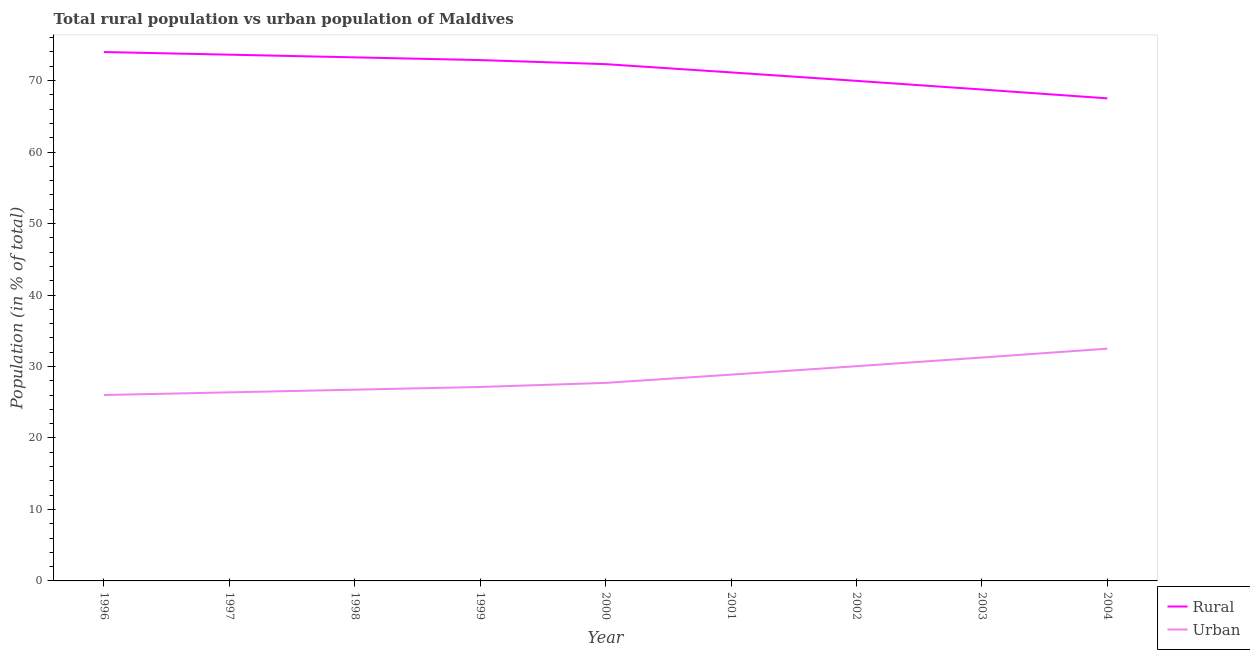Is the number of lines equal to the number of legend labels?
Offer a terse response. Yes. What is the rural population in 1999?
Ensure brevity in your answer.  72.87. Across all years, what is the maximum rural population?
Your answer should be compact. 73.99. Across all years, what is the minimum rural population?
Your answer should be compact. 67.51. What is the total urban population in the graph?
Give a very brief answer. 256.62. What is the difference between the rural population in 2002 and that in 2003?
Keep it short and to the point. 1.21. What is the difference between the rural population in 2004 and the urban population in 1997?
Your response must be concise. 41.13. What is the average urban population per year?
Make the answer very short. 28.51. In the year 1997, what is the difference between the urban population and rural population?
Keep it short and to the point. -47.24. In how many years, is the urban population greater than 34 %?
Give a very brief answer. 0. What is the ratio of the urban population in 1999 to that in 2002?
Your response must be concise. 0.9. Is the difference between the rural population in 1997 and 2004 greater than the difference between the urban population in 1997 and 2004?
Your response must be concise. Yes. What is the difference between the highest and the second highest rural population?
Your answer should be very brief. 0.37. What is the difference between the highest and the lowest rural population?
Offer a terse response. 6.48. In how many years, is the rural population greater than the average rural population taken over all years?
Your answer should be compact. 5. Is the rural population strictly greater than the urban population over the years?
Keep it short and to the point. Yes. Is the urban population strictly less than the rural population over the years?
Offer a terse response. Yes. Are the values on the major ticks of Y-axis written in scientific E-notation?
Keep it short and to the point. No. Does the graph contain any zero values?
Give a very brief answer. No. Does the graph contain grids?
Keep it short and to the point. No. Where does the legend appear in the graph?
Ensure brevity in your answer.  Bottom right. How many legend labels are there?
Your response must be concise. 2. What is the title of the graph?
Your answer should be compact. Total rural population vs urban population of Maldives. Does "Investment in Transport" appear as one of the legend labels in the graph?
Make the answer very short. No. What is the label or title of the Y-axis?
Offer a terse response. Population (in % of total). What is the Population (in % of total) in Rural in 1996?
Ensure brevity in your answer.  73.99. What is the Population (in % of total) in Urban in 1996?
Your response must be concise. 26.01. What is the Population (in % of total) of Rural in 1997?
Your answer should be compact. 73.62. What is the Population (in % of total) in Urban in 1997?
Provide a short and direct response. 26.38. What is the Population (in % of total) of Rural in 1998?
Ensure brevity in your answer.  73.25. What is the Population (in % of total) of Urban in 1998?
Offer a terse response. 26.75. What is the Population (in % of total) in Rural in 1999?
Offer a terse response. 72.87. What is the Population (in % of total) of Urban in 1999?
Ensure brevity in your answer.  27.13. What is the Population (in % of total) in Rural in 2000?
Your answer should be very brief. 72.29. What is the Population (in % of total) of Urban in 2000?
Provide a short and direct response. 27.71. What is the Population (in % of total) of Rural in 2001?
Your answer should be compact. 71.14. What is the Population (in % of total) in Urban in 2001?
Offer a terse response. 28.86. What is the Population (in % of total) of Rural in 2002?
Offer a very short reply. 69.96. What is the Population (in % of total) in Urban in 2002?
Offer a terse response. 30.04. What is the Population (in % of total) in Rural in 2003?
Offer a terse response. 68.75. What is the Population (in % of total) of Urban in 2003?
Your answer should be very brief. 31.25. What is the Population (in % of total) of Rural in 2004?
Provide a succinct answer. 67.51. What is the Population (in % of total) in Urban in 2004?
Provide a short and direct response. 32.49. Across all years, what is the maximum Population (in % of total) of Rural?
Your answer should be very brief. 73.99. Across all years, what is the maximum Population (in % of total) of Urban?
Offer a very short reply. 32.49. Across all years, what is the minimum Population (in % of total) of Rural?
Your response must be concise. 67.51. Across all years, what is the minimum Population (in % of total) in Urban?
Provide a short and direct response. 26.01. What is the total Population (in % of total) in Rural in the graph?
Keep it short and to the point. 643.38. What is the total Population (in % of total) of Urban in the graph?
Your answer should be very brief. 256.62. What is the difference between the Population (in % of total) in Rural in 1996 and that in 1997?
Your answer should be very brief. 0.37. What is the difference between the Population (in % of total) in Urban in 1996 and that in 1997?
Provide a short and direct response. -0.37. What is the difference between the Population (in % of total) in Rural in 1996 and that in 1998?
Provide a succinct answer. 0.75. What is the difference between the Population (in % of total) of Urban in 1996 and that in 1998?
Offer a terse response. -0.75. What is the difference between the Population (in % of total) of Rural in 1996 and that in 1999?
Provide a short and direct response. 1.13. What is the difference between the Population (in % of total) in Urban in 1996 and that in 1999?
Provide a short and direct response. -1.13. What is the difference between the Population (in % of total) in Rural in 1996 and that in 2000?
Your answer should be compact. 1.7. What is the difference between the Population (in % of total) of Urban in 1996 and that in 2000?
Your answer should be compact. -1.7. What is the difference between the Population (in % of total) of Rural in 1996 and that in 2001?
Offer a very short reply. 2.85. What is the difference between the Population (in % of total) of Urban in 1996 and that in 2001?
Provide a short and direct response. -2.85. What is the difference between the Population (in % of total) in Rural in 1996 and that in 2002?
Your answer should be very brief. 4.03. What is the difference between the Population (in % of total) in Urban in 1996 and that in 2002?
Provide a succinct answer. -4.03. What is the difference between the Population (in % of total) of Rural in 1996 and that in 2003?
Provide a succinct answer. 5.24. What is the difference between the Population (in % of total) in Urban in 1996 and that in 2003?
Offer a terse response. -5.24. What is the difference between the Population (in % of total) in Rural in 1996 and that in 2004?
Ensure brevity in your answer.  6.48. What is the difference between the Population (in % of total) in Urban in 1996 and that in 2004?
Make the answer very short. -6.48. What is the difference between the Population (in % of total) of Rural in 1997 and that in 1998?
Your answer should be compact. 0.38. What is the difference between the Population (in % of total) of Urban in 1997 and that in 1998?
Your response must be concise. -0.38. What is the difference between the Population (in % of total) of Rural in 1997 and that in 1999?
Offer a terse response. 0.76. What is the difference between the Population (in % of total) of Urban in 1997 and that in 1999?
Your response must be concise. -0.76. What is the difference between the Population (in % of total) of Rural in 1997 and that in 2000?
Make the answer very short. 1.33. What is the difference between the Population (in % of total) in Urban in 1997 and that in 2000?
Offer a terse response. -1.33. What is the difference between the Population (in % of total) of Rural in 1997 and that in 2001?
Give a very brief answer. 2.48. What is the difference between the Population (in % of total) in Urban in 1997 and that in 2001?
Offer a very short reply. -2.48. What is the difference between the Population (in % of total) of Rural in 1997 and that in 2002?
Keep it short and to the point. 3.66. What is the difference between the Population (in % of total) in Urban in 1997 and that in 2002?
Offer a terse response. -3.66. What is the difference between the Population (in % of total) of Rural in 1997 and that in 2003?
Offer a very short reply. 4.87. What is the difference between the Population (in % of total) of Urban in 1997 and that in 2003?
Make the answer very short. -4.87. What is the difference between the Population (in % of total) of Rural in 1997 and that in 2004?
Your response must be concise. 6.11. What is the difference between the Population (in % of total) in Urban in 1997 and that in 2004?
Provide a short and direct response. -6.11. What is the difference between the Population (in % of total) of Rural in 1998 and that in 1999?
Ensure brevity in your answer.  0.38. What is the difference between the Population (in % of total) of Urban in 1998 and that in 1999?
Provide a succinct answer. -0.38. What is the difference between the Population (in % of total) of Rural in 1998 and that in 2000?
Give a very brief answer. 0.95. What is the difference between the Population (in % of total) in Urban in 1998 and that in 2000?
Provide a succinct answer. -0.95. What is the difference between the Population (in % of total) of Rural in 1998 and that in 2001?
Ensure brevity in your answer.  2.1. What is the difference between the Population (in % of total) in Urban in 1998 and that in 2001?
Provide a succinct answer. -2.1. What is the difference between the Population (in % of total) of Rural in 1998 and that in 2002?
Offer a terse response. 3.29. What is the difference between the Population (in % of total) in Urban in 1998 and that in 2002?
Make the answer very short. -3.29. What is the difference between the Population (in % of total) in Rural in 1998 and that in 2003?
Your answer should be compact. 4.5. What is the difference between the Population (in % of total) of Urban in 1998 and that in 2003?
Give a very brief answer. -4.5. What is the difference between the Population (in % of total) in Rural in 1998 and that in 2004?
Your response must be concise. 5.74. What is the difference between the Population (in % of total) of Urban in 1998 and that in 2004?
Ensure brevity in your answer.  -5.74. What is the difference between the Population (in % of total) in Rural in 1999 and that in 2000?
Offer a terse response. 0.57. What is the difference between the Population (in % of total) of Urban in 1999 and that in 2000?
Offer a terse response. -0.57. What is the difference between the Population (in % of total) in Rural in 1999 and that in 2001?
Provide a succinct answer. 1.73. What is the difference between the Population (in % of total) of Urban in 1999 and that in 2001?
Your answer should be compact. -1.73. What is the difference between the Population (in % of total) in Rural in 1999 and that in 2002?
Offer a terse response. 2.91. What is the difference between the Population (in % of total) in Urban in 1999 and that in 2002?
Your response must be concise. -2.91. What is the difference between the Population (in % of total) of Rural in 1999 and that in 2003?
Make the answer very short. 4.12. What is the difference between the Population (in % of total) in Urban in 1999 and that in 2003?
Ensure brevity in your answer.  -4.12. What is the difference between the Population (in % of total) in Rural in 1999 and that in 2004?
Provide a succinct answer. 5.36. What is the difference between the Population (in % of total) in Urban in 1999 and that in 2004?
Provide a succinct answer. -5.36. What is the difference between the Population (in % of total) in Rural in 2000 and that in 2001?
Offer a terse response. 1.15. What is the difference between the Population (in % of total) of Urban in 2000 and that in 2001?
Your response must be concise. -1.15. What is the difference between the Population (in % of total) of Rural in 2000 and that in 2002?
Your answer should be compact. 2.34. What is the difference between the Population (in % of total) of Urban in 2000 and that in 2002?
Ensure brevity in your answer.  -2.34. What is the difference between the Population (in % of total) in Rural in 2000 and that in 2003?
Your answer should be very brief. 3.55. What is the difference between the Population (in % of total) in Urban in 2000 and that in 2003?
Your answer should be very brief. -3.55. What is the difference between the Population (in % of total) in Rural in 2000 and that in 2004?
Ensure brevity in your answer.  4.78. What is the difference between the Population (in % of total) in Urban in 2000 and that in 2004?
Offer a terse response. -4.78. What is the difference between the Population (in % of total) in Rural in 2001 and that in 2002?
Provide a succinct answer. 1.18. What is the difference between the Population (in % of total) of Urban in 2001 and that in 2002?
Give a very brief answer. -1.18. What is the difference between the Population (in % of total) in Rural in 2001 and that in 2003?
Your answer should be very brief. 2.39. What is the difference between the Population (in % of total) of Urban in 2001 and that in 2003?
Offer a very short reply. -2.39. What is the difference between the Population (in % of total) in Rural in 2001 and that in 2004?
Ensure brevity in your answer.  3.63. What is the difference between the Population (in % of total) in Urban in 2001 and that in 2004?
Provide a short and direct response. -3.63. What is the difference between the Population (in % of total) in Rural in 2002 and that in 2003?
Keep it short and to the point. 1.21. What is the difference between the Population (in % of total) in Urban in 2002 and that in 2003?
Ensure brevity in your answer.  -1.21. What is the difference between the Population (in % of total) of Rural in 2002 and that in 2004?
Give a very brief answer. 2.45. What is the difference between the Population (in % of total) of Urban in 2002 and that in 2004?
Provide a short and direct response. -2.45. What is the difference between the Population (in % of total) of Rural in 2003 and that in 2004?
Your answer should be compact. 1.24. What is the difference between the Population (in % of total) in Urban in 2003 and that in 2004?
Give a very brief answer. -1.24. What is the difference between the Population (in % of total) of Rural in 1996 and the Population (in % of total) of Urban in 1997?
Provide a short and direct response. 47.61. What is the difference between the Population (in % of total) of Rural in 1996 and the Population (in % of total) of Urban in 1998?
Your answer should be compact. 47.24. What is the difference between the Population (in % of total) in Rural in 1996 and the Population (in % of total) in Urban in 1999?
Give a very brief answer. 46.86. What is the difference between the Population (in % of total) of Rural in 1996 and the Population (in % of total) of Urban in 2000?
Offer a terse response. 46.29. What is the difference between the Population (in % of total) in Rural in 1996 and the Population (in % of total) in Urban in 2001?
Provide a short and direct response. 45.13. What is the difference between the Population (in % of total) of Rural in 1996 and the Population (in % of total) of Urban in 2002?
Give a very brief answer. 43.95. What is the difference between the Population (in % of total) in Rural in 1996 and the Population (in % of total) in Urban in 2003?
Provide a succinct answer. 42.74. What is the difference between the Population (in % of total) in Rural in 1996 and the Population (in % of total) in Urban in 2004?
Offer a terse response. 41.5. What is the difference between the Population (in % of total) of Rural in 1997 and the Population (in % of total) of Urban in 1998?
Offer a very short reply. 46.87. What is the difference between the Population (in % of total) in Rural in 1997 and the Population (in % of total) in Urban in 1999?
Keep it short and to the point. 46.49. What is the difference between the Population (in % of total) of Rural in 1997 and the Population (in % of total) of Urban in 2000?
Your response must be concise. 45.91. What is the difference between the Population (in % of total) of Rural in 1997 and the Population (in % of total) of Urban in 2001?
Your answer should be compact. 44.76. What is the difference between the Population (in % of total) in Rural in 1997 and the Population (in % of total) in Urban in 2002?
Offer a terse response. 43.58. What is the difference between the Population (in % of total) of Rural in 1997 and the Population (in % of total) of Urban in 2003?
Offer a very short reply. 42.37. What is the difference between the Population (in % of total) in Rural in 1997 and the Population (in % of total) in Urban in 2004?
Ensure brevity in your answer.  41.13. What is the difference between the Population (in % of total) in Rural in 1998 and the Population (in % of total) in Urban in 1999?
Your response must be concise. 46.11. What is the difference between the Population (in % of total) of Rural in 1998 and the Population (in % of total) of Urban in 2000?
Offer a very short reply. 45.54. What is the difference between the Population (in % of total) of Rural in 1998 and the Population (in % of total) of Urban in 2001?
Offer a terse response. 44.39. What is the difference between the Population (in % of total) in Rural in 1998 and the Population (in % of total) in Urban in 2002?
Your response must be concise. 43.2. What is the difference between the Population (in % of total) of Rural in 1998 and the Population (in % of total) of Urban in 2003?
Make the answer very short. 41.99. What is the difference between the Population (in % of total) of Rural in 1998 and the Population (in % of total) of Urban in 2004?
Make the answer very short. 40.76. What is the difference between the Population (in % of total) of Rural in 1999 and the Population (in % of total) of Urban in 2000?
Your answer should be compact. 45.16. What is the difference between the Population (in % of total) in Rural in 1999 and the Population (in % of total) in Urban in 2001?
Provide a succinct answer. 44.01. What is the difference between the Population (in % of total) in Rural in 1999 and the Population (in % of total) in Urban in 2002?
Offer a terse response. 42.82. What is the difference between the Population (in % of total) in Rural in 1999 and the Population (in % of total) in Urban in 2003?
Offer a very short reply. 41.61. What is the difference between the Population (in % of total) of Rural in 1999 and the Population (in % of total) of Urban in 2004?
Keep it short and to the point. 40.38. What is the difference between the Population (in % of total) of Rural in 2000 and the Population (in % of total) of Urban in 2001?
Give a very brief answer. 43.44. What is the difference between the Population (in % of total) in Rural in 2000 and the Population (in % of total) in Urban in 2002?
Your response must be concise. 42.25. What is the difference between the Population (in % of total) of Rural in 2000 and the Population (in % of total) of Urban in 2003?
Your response must be concise. 41.04. What is the difference between the Population (in % of total) in Rural in 2000 and the Population (in % of total) in Urban in 2004?
Offer a very short reply. 39.8. What is the difference between the Population (in % of total) in Rural in 2001 and the Population (in % of total) in Urban in 2002?
Give a very brief answer. 41.1. What is the difference between the Population (in % of total) of Rural in 2001 and the Population (in % of total) of Urban in 2003?
Give a very brief answer. 39.89. What is the difference between the Population (in % of total) in Rural in 2001 and the Population (in % of total) in Urban in 2004?
Offer a terse response. 38.65. What is the difference between the Population (in % of total) of Rural in 2002 and the Population (in % of total) of Urban in 2003?
Ensure brevity in your answer.  38.71. What is the difference between the Population (in % of total) in Rural in 2002 and the Population (in % of total) in Urban in 2004?
Keep it short and to the point. 37.47. What is the difference between the Population (in % of total) of Rural in 2003 and the Population (in % of total) of Urban in 2004?
Offer a very short reply. 36.26. What is the average Population (in % of total) of Rural per year?
Keep it short and to the point. 71.49. What is the average Population (in % of total) of Urban per year?
Provide a short and direct response. 28.51. In the year 1996, what is the difference between the Population (in % of total) in Rural and Population (in % of total) in Urban?
Provide a succinct answer. 47.98. In the year 1997, what is the difference between the Population (in % of total) of Rural and Population (in % of total) of Urban?
Your response must be concise. 47.24. In the year 1998, what is the difference between the Population (in % of total) of Rural and Population (in % of total) of Urban?
Make the answer very short. 46.49. In the year 1999, what is the difference between the Population (in % of total) in Rural and Population (in % of total) in Urban?
Keep it short and to the point. 45.73. In the year 2000, what is the difference between the Population (in % of total) in Rural and Population (in % of total) in Urban?
Offer a terse response. 44.59. In the year 2001, what is the difference between the Population (in % of total) in Rural and Population (in % of total) in Urban?
Give a very brief answer. 42.28. In the year 2002, what is the difference between the Population (in % of total) in Rural and Population (in % of total) in Urban?
Make the answer very short. 39.92. In the year 2003, what is the difference between the Population (in % of total) in Rural and Population (in % of total) in Urban?
Keep it short and to the point. 37.5. In the year 2004, what is the difference between the Population (in % of total) of Rural and Population (in % of total) of Urban?
Keep it short and to the point. 35.02. What is the ratio of the Population (in % of total) in Urban in 1996 to that in 1997?
Offer a very short reply. 0.99. What is the ratio of the Population (in % of total) of Rural in 1996 to that in 1998?
Offer a very short reply. 1.01. What is the ratio of the Population (in % of total) in Urban in 1996 to that in 1998?
Offer a very short reply. 0.97. What is the ratio of the Population (in % of total) of Rural in 1996 to that in 1999?
Provide a succinct answer. 1.02. What is the ratio of the Population (in % of total) in Urban in 1996 to that in 1999?
Offer a terse response. 0.96. What is the ratio of the Population (in % of total) in Rural in 1996 to that in 2000?
Your answer should be very brief. 1.02. What is the ratio of the Population (in % of total) of Urban in 1996 to that in 2000?
Provide a succinct answer. 0.94. What is the ratio of the Population (in % of total) in Rural in 1996 to that in 2001?
Your answer should be compact. 1.04. What is the ratio of the Population (in % of total) in Urban in 1996 to that in 2001?
Provide a short and direct response. 0.9. What is the ratio of the Population (in % of total) in Rural in 1996 to that in 2002?
Provide a succinct answer. 1.06. What is the ratio of the Population (in % of total) in Urban in 1996 to that in 2002?
Your response must be concise. 0.87. What is the ratio of the Population (in % of total) of Rural in 1996 to that in 2003?
Ensure brevity in your answer.  1.08. What is the ratio of the Population (in % of total) of Urban in 1996 to that in 2003?
Your answer should be very brief. 0.83. What is the ratio of the Population (in % of total) of Rural in 1996 to that in 2004?
Provide a short and direct response. 1.1. What is the ratio of the Population (in % of total) in Urban in 1996 to that in 2004?
Provide a short and direct response. 0.8. What is the ratio of the Population (in % of total) in Rural in 1997 to that in 1998?
Ensure brevity in your answer.  1.01. What is the ratio of the Population (in % of total) of Urban in 1997 to that in 1998?
Make the answer very short. 0.99. What is the ratio of the Population (in % of total) of Rural in 1997 to that in 1999?
Ensure brevity in your answer.  1.01. What is the ratio of the Population (in % of total) of Urban in 1997 to that in 1999?
Your response must be concise. 0.97. What is the ratio of the Population (in % of total) of Rural in 1997 to that in 2000?
Keep it short and to the point. 1.02. What is the ratio of the Population (in % of total) in Urban in 1997 to that in 2000?
Offer a very short reply. 0.95. What is the ratio of the Population (in % of total) in Rural in 1997 to that in 2001?
Your response must be concise. 1.03. What is the ratio of the Population (in % of total) of Urban in 1997 to that in 2001?
Your answer should be very brief. 0.91. What is the ratio of the Population (in % of total) in Rural in 1997 to that in 2002?
Give a very brief answer. 1.05. What is the ratio of the Population (in % of total) of Urban in 1997 to that in 2002?
Keep it short and to the point. 0.88. What is the ratio of the Population (in % of total) in Rural in 1997 to that in 2003?
Make the answer very short. 1.07. What is the ratio of the Population (in % of total) in Urban in 1997 to that in 2003?
Make the answer very short. 0.84. What is the ratio of the Population (in % of total) in Rural in 1997 to that in 2004?
Provide a succinct answer. 1.09. What is the ratio of the Population (in % of total) in Urban in 1997 to that in 2004?
Provide a short and direct response. 0.81. What is the ratio of the Population (in % of total) in Urban in 1998 to that in 1999?
Ensure brevity in your answer.  0.99. What is the ratio of the Population (in % of total) in Rural in 1998 to that in 2000?
Your answer should be very brief. 1.01. What is the ratio of the Population (in % of total) in Urban in 1998 to that in 2000?
Provide a succinct answer. 0.97. What is the ratio of the Population (in % of total) of Rural in 1998 to that in 2001?
Provide a short and direct response. 1.03. What is the ratio of the Population (in % of total) in Urban in 1998 to that in 2001?
Offer a terse response. 0.93. What is the ratio of the Population (in % of total) of Rural in 1998 to that in 2002?
Your response must be concise. 1.05. What is the ratio of the Population (in % of total) of Urban in 1998 to that in 2002?
Provide a short and direct response. 0.89. What is the ratio of the Population (in % of total) in Rural in 1998 to that in 2003?
Offer a very short reply. 1.07. What is the ratio of the Population (in % of total) of Urban in 1998 to that in 2003?
Provide a succinct answer. 0.86. What is the ratio of the Population (in % of total) of Rural in 1998 to that in 2004?
Your answer should be compact. 1.08. What is the ratio of the Population (in % of total) of Urban in 1998 to that in 2004?
Keep it short and to the point. 0.82. What is the ratio of the Population (in % of total) of Rural in 1999 to that in 2000?
Give a very brief answer. 1.01. What is the ratio of the Population (in % of total) in Urban in 1999 to that in 2000?
Provide a short and direct response. 0.98. What is the ratio of the Population (in % of total) of Rural in 1999 to that in 2001?
Your answer should be very brief. 1.02. What is the ratio of the Population (in % of total) in Urban in 1999 to that in 2001?
Provide a short and direct response. 0.94. What is the ratio of the Population (in % of total) in Rural in 1999 to that in 2002?
Provide a succinct answer. 1.04. What is the ratio of the Population (in % of total) of Urban in 1999 to that in 2002?
Provide a short and direct response. 0.9. What is the ratio of the Population (in % of total) of Rural in 1999 to that in 2003?
Give a very brief answer. 1.06. What is the ratio of the Population (in % of total) in Urban in 1999 to that in 2003?
Offer a very short reply. 0.87. What is the ratio of the Population (in % of total) of Rural in 1999 to that in 2004?
Your answer should be very brief. 1.08. What is the ratio of the Population (in % of total) of Urban in 1999 to that in 2004?
Give a very brief answer. 0.84. What is the ratio of the Population (in % of total) of Rural in 2000 to that in 2001?
Provide a short and direct response. 1.02. What is the ratio of the Population (in % of total) in Rural in 2000 to that in 2002?
Provide a succinct answer. 1.03. What is the ratio of the Population (in % of total) of Urban in 2000 to that in 2002?
Make the answer very short. 0.92. What is the ratio of the Population (in % of total) in Rural in 2000 to that in 2003?
Offer a very short reply. 1.05. What is the ratio of the Population (in % of total) in Urban in 2000 to that in 2003?
Ensure brevity in your answer.  0.89. What is the ratio of the Population (in % of total) of Rural in 2000 to that in 2004?
Keep it short and to the point. 1.07. What is the ratio of the Population (in % of total) in Urban in 2000 to that in 2004?
Provide a short and direct response. 0.85. What is the ratio of the Population (in % of total) of Rural in 2001 to that in 2002?
Your response must be concise. 1.02. What is the ratio of the Population (in % of total) of Urban in 2001 to that in 2002?
Keep it short and to the point. 0.96. What is the ratio of the Population (in % of total) of Rural in 2001 to that in 2003?
Your answer should be very brief. 1.03. What is the ratio of the Population (in % of total) in Urban in 2001 to that in 2003?
Offer a very short reply. 0.92. What is the ratio of the Population (in % of total) of Rural in 2001 to that in 2004?
Ensure brevity in your answer.  1.05. What is the ratio of the Population (in % of total) in Urban in 2001 to that in 2004?
Ensure brevity in your answer.  0.89. What is the ratio of the Population (in % of total) of Rural in 2002 to that in 2003?
Provide a short and direct response. 1.02. What is the ratio of the Population (in % of total) of Urban in 2002 to that in 2003?
Give a very brief answer. 0.96. What is the ratio of the Population (in % of total) of Rural in 2002 to that in 2004?
Provide a short and direct response. 1.04. What is the ratio of the Population (in % of total) in Urban in 2002 to that in 2004?
Give a very brief answer. 0.92. What is the ratio of the Population (in % of total) of Rural in 2003 to that in 2004?
Your response must be concise. 1.02. What is the ratio of the Population (in % of total) in Urban in 2003 to that in 2004?
Give a very brief answer. 0.96. What is the difference between the highest and the second highest Population (in % of total) in Rural?
Ensure brevity in your answer.  0.37. What is the difference between the highest and the second highest Population (in % of total) of Urban?
Offer a terse response. 1.24. What is the difference between the highest and the lowest Population (in % of total) of Rural?
Your response must be concise. 6.48. What is the difference between the highest and the lowest Population (in % of total) in Urban?
Provide a succinct answer. 6.48. 